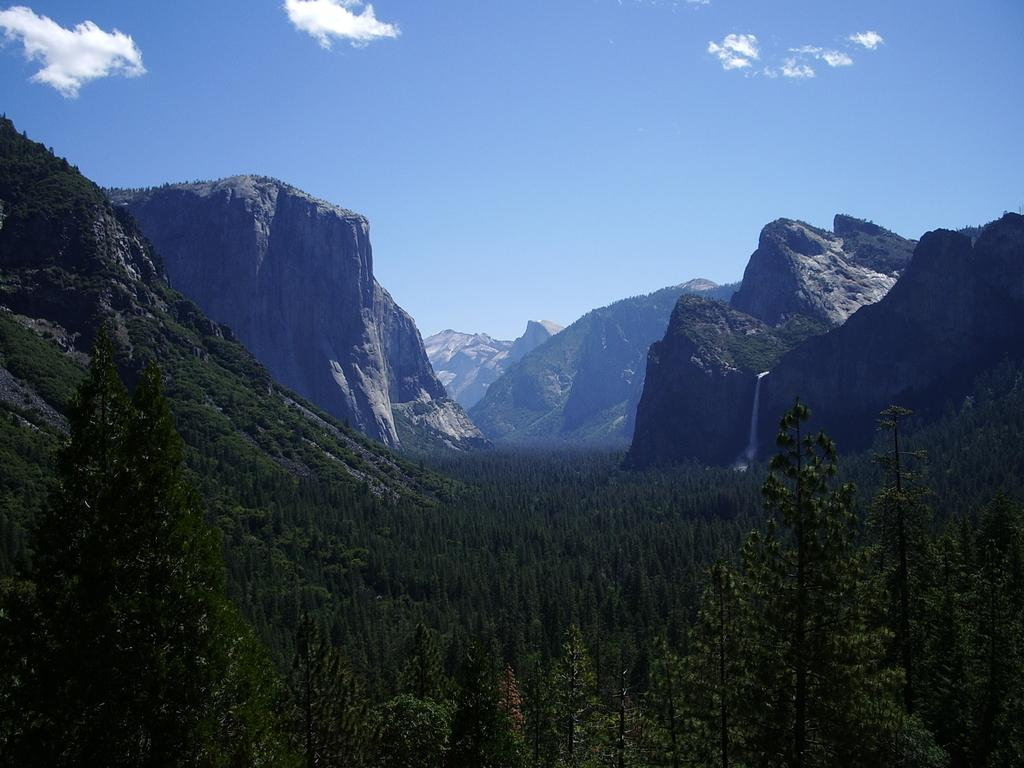What type of landscape can be seen in the image? There are hills in the image. What other natural elements are present in the image? There are trees in the image. How would you describe the sky in the image? The sky is blue and cloudy in the image. What type of feeling is expressed by the committee in the image? There is no committee present in the image, so it is not possible to determine any feelings expressed by a committee. 